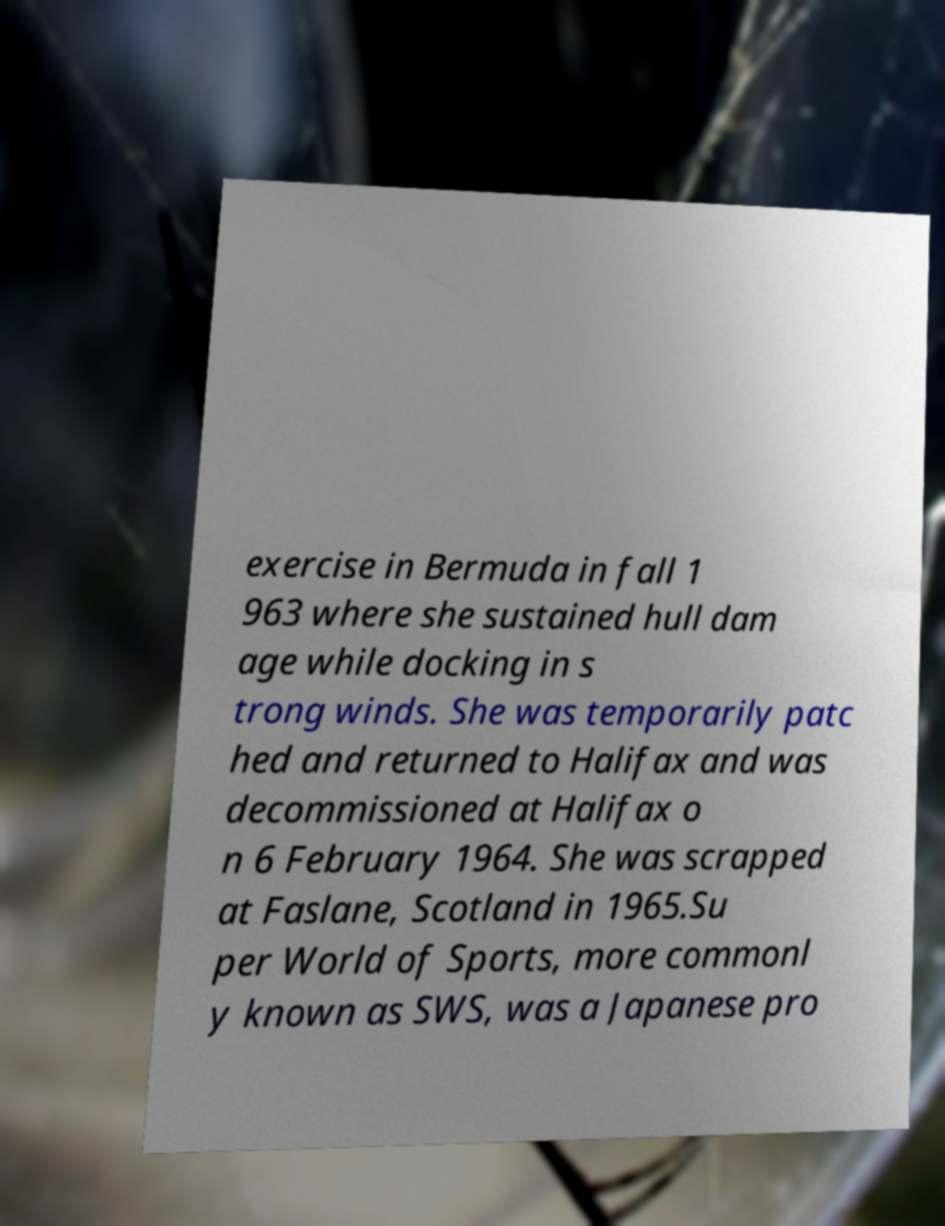There's text embedded in this image that I need extracted. Can you transcribe it verbatim? exercise in Bermuda in fall 1 963 where she sustained hull dam age while docking in s trong winds. She was temporarily patc hed and returned to Halifax and was decommissioned at Halifax o n 6 February 1964. She was scrapped at Faslane, Scotland in 1965.Su per World of Sports, more commonl y known as SWS, was a Japanese pro 